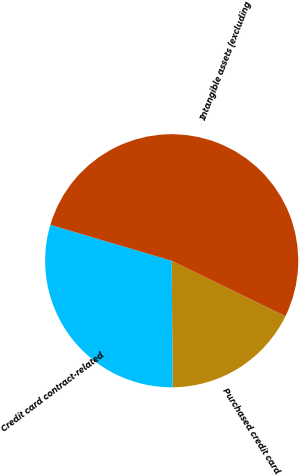Convert chart. <chart><loc_0><loc_0><loc_500><loc_500><pie_chart><fcel>Purchased credit card<fcel>Credit card contract-related<fcel>Intangible assets (excluding<nl><fcel>17.66%<fcel>29.7%<fcel>52.64%<nl></chart> 